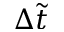Convert formula to latex. <formula><loc_0><loc_0><loc_500><loc_500>\Delta \tilde { t }</formula> 